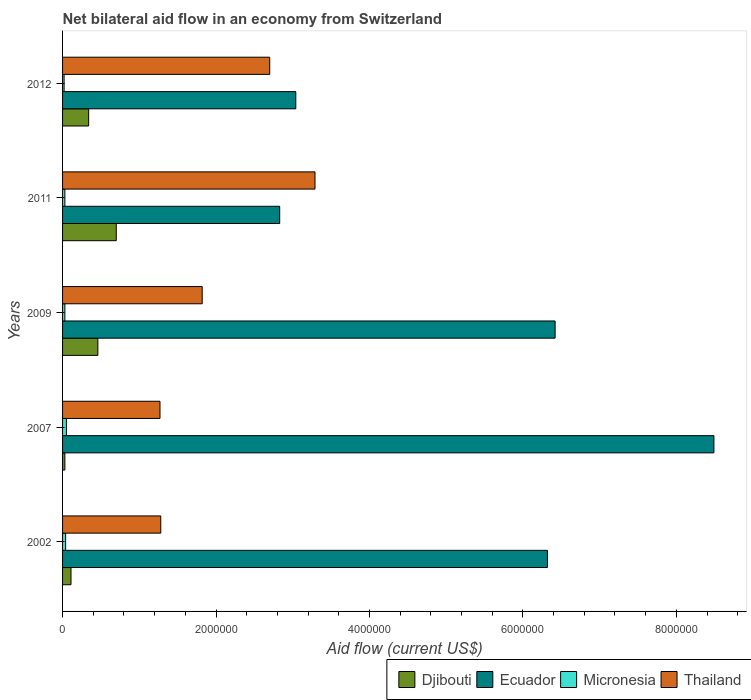How many different coloured bars are there?
Your answer should be compact. 4. How many groups of bars are there?
Your answer should be compact. 5. How many bars are there on the 5th tick from the bottom?
Offer a very short reply. 4. Across all years, what is the minimum net bilateral aid flow in Micronesia?
Your response must be concise. 2.00e+04. In which year was the net bilateral aid flow in Ecuador maximum?
Provide a short and direct response. 2007. In which year was the net bilateral aid flow in Ecuador minimum?
Provide a short and direct response. 2011. What is the total net bilateral aid flow in Djibouti in the graph?
Ensure brevity in your answer.  1.64e+06. What is the difference between the net bilateral aid flow in Thailand in 2002 and that in 2009?
Your response must be concise. -5.40e+05. What is the difference between the net bilateral aid flow in Djibouti in 2007 and the net bilateral aid flow in Thailand in 2002?
Your answer should be very brief. -1.25e+06. What is the average net bilateral aid flow in Micronesia per year?
Your response must be concise. 3.40e+04. In the year 2007, what is the difference between the net bilateral aid flow in Ecuador and net bilateral aid flow in Micronesia?
Provide a succinct answer. 8.44e+06. In how many years, is the net bilateral aid flow in Ecuador greater than 6400000 US$?
Provide a succinct answer. 2. What is the ratio of the net bilateral aid flow in Micronesia in 2002 to that in 2011?
Provide a short and direct response. 1.33. Is the net bilateral aid flow in Djibouti in 2009 less than that in 2012?
Make the answer very short. No. Is the difference between the net bilateral aid flow in Ecuador in 2002 and 2009 greater than the difference between the net bilateral aid flow in Micronesia in 2002 and 2009?
Offer a very short reply. No. What is the difference between the highest and the second highest net bilateral aid flow in Ecuador?
Your response must be concise. 2.07e+06. What is the difference between the highest and the lowest net bilateral aid flow in Djibouti?
Keep it short and to the point. 6.70e+05. Is the sum of the net bilateral aid flow in Thailand in 2011 and 2012 greater than the maximum net bilateral aid flow in Ecuador across all years?
Keep it short and to the point. No. Is it the case that in every year, the sum of the net bilateral aid flow in Ecuador and net bilateral aid flow in Djibouti is greater than the sum of net bilateral aid flow in Micronesia and net bilateral aid flow in Thailand?
Offer a very short reply. Yes. What does the 4th bar from the top in 2011 represents?
Your answer should be compact. Djibouti. What does the 1st bar from the bottom in 2007 represents?
Make the answer very short. Djibouti. Are the values on the major ticks of X-axis written in scientific E-notation?
Offer a very short reply. No. How many legend labels are there?
Your answer should be compact. 4. What is the title of the graph?
Your response must be concise. Net bilateral aid flow in an economy from Switzerland. Does "Ecuador" appear as one of the legend labels in the graph?
Your answer should be compact. Yes. What is the Aid flow (current US$) of Ecuador in 2002?
Ensure brevity in your answer.  6.32e+06. What is the Aid flow (current US$) in Thailand in 2002?
Give a very brief answer. 1.28e+06. What is the Aid flow (current US$) of Ecuador in 2007?
Your answer should be very brief. 8.49e+06. What is the Aid flow (current US$) of Micronesia in 2007?
Keep it short and to the point. 5.00e+04. What is the Aid flow (current US$) in Thailand in 2007?
Your answer should be compact. 1.27e+06. What is the Aid flow (current US$) of Ecuador in 2009?
Keep it short and to the point. 6.42e+06. What is the Aid flow (current US$) in Micronesia in 2009?
Make the answer very short. 3.00e+04. What is the Aid flow (current US$) of Thailand in 2009?
Your answer should be compact. 1.82e+06. What is the Aid flow (current US$) in Ecuador in 2011?
Provide a succinct answer. 2.83e+06. What is the Aid flow (current US$) in Thailand in 2011?
Your response must be concise. 3.29e+06. What is the Aid flow (current US$) of Ecuador in 2012?
Keep it short and to the point. 3.04e+06. What is the Aid flow (current US$) in Thailand in 2012?
Ensure brevity in your answer.  2.70e+06. Across all years, what is the maximum Aid flow (current US$) in Djibouti?
Ensure brevity in your answer.  7.00e+05. Across all years, what is the maximum Aid flow (current US$) in Ecuador?
Your answer should be very brief. 8.49e+06. Across all years, what is the maximum Aid flow (current US$) of Micronesia?
Your answer should be compact. 5.00e+04. Across all years, what is the maximum Aid flow (current US$) in Thailand?
Give a very brief answer. 3.29e+06. Across all years, what is the minimum Aid flow (current US$) of Ecuador?
Ensure brevity in your answer.  2.83e+06. Across all years, what is the minimum Aid flow (current US$) of Micronesia?
Offer a very short reply. 2.00e+04. Across all years, what is the minimum Aid flow (current US$) of Thailand?
Make the answer very short. 1.27e+06. What is the total Aid flow (current US$) of Djibouti in the graph?
Your answer should be very brief. 1.64e+06. What is the total Aid flow (current US$) in Ecuador in the graph?
Your answer should be compact. 2.71e+07. What is the total Aid flow (current US$) in Thailand in the graph?
Offer a very short reply. 1.04e+07. What is the difference between the Aid flow (current US$) of Ecuador in 2002 and that in 2007?
Your answer should be compact. -2.17e+06. What is the difference between the Aid flow (current US$) of Thailand in 2002 and that in 2007?
Give a very brief answer. 10000. What is the difference between the Aid flow (current US$) of Djibouti in 2002 and that in 2009?
Your response must be concise. -3.50e+05. What is the difference between the Aid flow (current US$) of Ecuador in 2002 and that in 2009?
Offer a very short reply. -1.00e+05. What is the difference between the Aid flow (current US$) in Thailand in 2002 and that in 2009?
Your answer should be compact. -5.40e+05. What is the difference between the Aid flow (current US$) of Djibouti in 2002 and that in 2011?
Offer a very short reply. -5.90e+05. What is the difference between the Aid flow (current US$) of Ecuador in 2002 and that in 2011?
Your response must be concise. 3.49e+06. What is the difference between the Aid flow (current US$) of Micronesia in 2002 and that in 2011?
Give a very brief answer. 10000. What is the difference between the Aid flow (current US$) of Thailand in 2002 and that in 2011?
Provide a short and direct response. -2.01e+06. What is the difference between the Aid flow (current US$) in Djibouti in 2002 and that in 2012?
Provide a succinct answer. -2.30e+05. What is the difference between the Aid flow (current US$) in Ecuador in 2002 and that in 2012?
Your response must be concise. 3.28e+06. What is the difference between the Aid flow (current US$) in Thailand in 2002 and that in 2012?
Keep it short and to the point. -1.42e+06. What is the difference between the Aid flow (current US$) of Djibouti in 2007 and that in 2009?
Your response must be concise. -4.30e+05. What is the difference between the Aid flow (current US$) of Ecuador in 2007 and that in 2009?
Keep it short and to the point. 2.07e+06. What is the difference between the Aid flow (current US$) of Thailand in 2007 and that in 2009?
Your answer should be very brief. -5.50e+05. What is the difference between the Aid flow (current US$) in Djibouti in 2007 and that in 2011?
Your answer should be compact. -6.70e+05. What is the difference between the Aid flow (current US$) of Ecuador in 2007 and that in 2011?
Your answer should be very brief. 5.66e+06. What is the difference between the Aid flow (current US$) of Thailand in 2007 and that in 2011?
Provide a succinct answer. -2.02e+06. What is the difference between the Aid flow (current US$) of Djibouti in 2007 and that in 2012?
Your response must be concise. -3.10e+05. What is the difference between the Aid flow (current US$) in Ecuador in 2007 and that in 2012?
Provide a short and direct response. 5.45e+06. What is the difference between the Aid flow (current US$) in Micronesia in 2007 and that in 2012?
Your answer should be compact. 3.00e+04. What is the difference between the Aid flow (current US$) of Thailand in 2007 and that in 2012?
Ensure brevity in your answer.  -1.43e+06. What is the difference between the Aid flow (current US$) of Djibouti in 2009 and that in 2011?
Ensure brevity in your answer.  -2.40e+05. What is the difference between the Aid flow (current US$) of Ecuador in 2009 and that in 2011?
Provide a succinct answer. 3.59e+06. What is the difference between the Aid flow (current US$) in Thailand in 2009 and that in 2011?
Your answer should be very brief. -1.47e+06. What is the difference between the Aid flow (current US$) in Djibouti in 2009 and that in 2012?
Provide a short and direct response. 1.20e+05. What is the difference between the Aid flow (current US$) in Ecuador in 2009 and that in 2012?
Your response must be concise. 3.38e+06. What is the difference between the Aid flow (current US$) in Thailand in 2009 and that in 2012?
Offer a terse response. -8.80e+05. What is the difference between the Aid flow (current US$) in Ecuador in 2011 and that in 2012?
Keep it short and to the point. -2.10e+05. What is the difference between the Aid flow (current US$) of Micronesia in 2011 and that in 2012?
Your response must be concise. 10000. What is the difference between the Aid flow (current US$) of Thailand in 2011 and that in 2012?
Your answer should be very brief. 5.90e+05. What is the difference between the Aid flow (current US$) in Djibouti in 2002 and the Aid flow (current US$) in Ecuador in 2007?
Ensure brevity in your answer.  -8.38e+06. What is the difference between the Aid flow (current US$) in Djibouti in 2002 and the Aid flow (current US$) in Micronesia in 2007?
Offer a very short reply. 6.00e+04. What is the difference between the Aid flow (current US$) in Djibouti in 2002 and the Aid flow (current US$) in Thailand in 2007?
Offer a terse response. -1.16e+06. What is the difference between the Aid flow (current US$) in Ecuador in 2002 and the Aid flow (current US$) in Micronesia in 2007?
Ensure brevity in your answer.  6.27e+06. What is the difference between the Aid flow (current US$) in Ecuador in 2002 and the Aid flow (current US$) in Thailand in 2007?
Make the answer very short. 5.05e+06. What is the difference between the Aid flow (current US$) of Micronesia in 2002 and the Aid flow (current US$) of Thailand in 2007?
Provide a succinct answer. -1.23e+06. What is the difference between the Aid flow (current US$) of Djibouti in 2002 and the Aid flow (current US$) of Ecuador in 2009?
Offer a very short reply. -6.31e+06. What is the difference between the Aid flow (current US$) in Djibouti in 2002 and the Aid flow (current US$) in Micronesia in 2009?
Provide a short and direct response. 8.00e+04. What is the difference between the Aid flow (current US$) of Djibouti in 2002 and the Aid flow (current US$) of Thailand in 2009?
Your response must be concise. -1.71e+06. What is the difference between the Aid flow (current US$) of Ecuador in 2002 and the Aid flow (current US$) of Micronesia in 2009?
Give a very brief answer. 6.29e+06. What is the difference between the Aid flow (current US$) in Ecuador in 2002 and the Aid flow (current US$) in Thailand in 2009?
Provide a succinct answer. 4.50e+06. What is the difference between the Aid flow (current US$) in Micronesia in 2002 and the Aid flow (current US$) in Thailand in 2009?
Give a very brief answer. -1.78e+06. What is the difference between the Aid flow (current US$) of Djibouti in 2002 and the Aid flow (current US$) of Ecuador in 2011?
Offer a very short reply. -2.72e+06. What is the difference between the Aid flow (current US$) of Djibouti in 2002 and the Aid flow (current US$) of Micronesia in 2011?
Ensure brevity in your answer.  8.00e+04. What is the difference between the Aid flow (current US$) in Djibouti in 2002 and the Aid flow (current US$) in Thailand in 2011?
Offer a very short reply. -3.18e+06. What is the difference between the Aid flow (current US$) in Ecuador in 2002 and the Aid flow (current US$) in Micronesia in 2011?
Keep it short and to the point. 6.29e+06. What is the difference between the Aid flow (current US$) in Ecuador in 2002 and the Aid flow (current US$) in Thailand in 2011?
Give a very brief answer. 3.03e+06. What is the difference between the Aid flow (current US$) of Micronesia in 2002 and the Aid flow (current US$) of Thailand in 2011?
Offer a very short reply. -3.25e+06. What is the difference between the Aid flow (current US$) of Djibouti in 2002 and the Aid flow (current US$) of Ecuador in 2012?
Make the answer very short. -2.93e+06. What is the difference between the Aid flow (current US$) in Djibouti in 2002 and the Aid flow (current US$) in Thailand in 2012?
Your answer should be compact. -2.59e+06. What is the difference between the Aid flow (current US$) of Ecuador in 2002 and the Aid flow (current US$) of Micronesia in 2012?
Your answer should be compact. 6.30e+06. What is the difference between the Aid flow (current US$) in Ecuador in 2002 and the Aid flow (current US$) in Thailand in 2012?
Your answer should be very brief. 3.62e+06. What is the difference between the Aid flow (current US$) in Micronesia in 2002 and the Aid flow (current US$) in Thailand in 2012?
Offer a very short reply. -2.66e+06. What is the difference between the Aid flow (current US$) in Djibouti in 2007 and the Aid flow (current US$) in Ecuador in 2009?
Provide a short and direct response. -6.39e+06. What is the difference between the Aid flow (current US$) in Djibouti in 2007 and the Aid flow (current US$) in Thailand in 2009?
Your response must be concise. -1.79e+06. What is the difference between the Aid flow (current US$) of Ecuador in 2007 and the Aid flow (current US$) of Micronesia in 2009?
Your answer should be compact. 8.46e+06. What is the difference between the Aid flow (current US$) of Ecuador in 2007 and the Aid flow (current US$) of Thailand in 2009?
Your answer should be compact. 6.67e+06. What is the difference between the Aid flow (current US$) of Micronesia in 2007 and the Aid flow (current US$) of Thailand in 2009?
Offer a terse response. -1.77e+06. What is the difference between the Aid flow (current US$) in Djibouti in 2007 and the Aid flow (current US$) in Ecuador in 2011?
Your response must be concise. -2.80e+06. What is the difference between the Aid flow (current US$) of Djibouti in 2007 and the Aid flow (current US$) of Thailand in 2011?
Provide a succinct answer. -3.26e+06. What is the difference between the Aid flow (current US$) of Ecuador in 2007 and the Aid flow (current US$) of Micronesia in 2011?
Make the answer very short. 8.46e+06. What is the difference between the Aid flow (current US$) in Ecuador in 2007 and the Aid flow (current US$) in Thailand in 2011?
Your answer should be compact. 5.20e+06. What is the difference between the Aid flow (current US$) in Micronesia in 2007 and the Aid flow (current US$) in Thailand in 2011?
Keep it short and to the point. -3.24e+06. What is the difference between the Aid flow (current US$) in Djibouti in 2007 and the Aid flow (current US$) in Ecuador in 2012?
Provide a succinct answer. -3.01e+06. What is the difference between the Aid flow (current US$) of Djibouti in 2007 and the Aid flow (current US$) of Thailand in 2012?
Make the answer very short. -2.67e+06. What is the difference between the Aid flow (current US$) in Ecuador in 2007 and the Aid flow (current US$) in Micronesia in 2012?
Make the answer very short. 8.47e+06. What is the difference between the Aid flow (current US$) in Ecuador in 2007 and the Aid flow (current US$) in Thailand in 2012?
Make the answer very short. 5.79e+06. What is the difference between the Aid flow (current US$) in Micronesia in 2007 and the Aid flow (current US$) in Thailand in 2012?
Keep it short and to the point. -2.65e+06. What is the difference between the Aid flow (current US$) of Djibouti in 2009 and the Aid flow (current US$) of Ecuador in 2011?
Keep it short and to the point. -2.37e+06. What is the difference between the Aid flow (current US$) of Djibouti in 2009 and the Aid flow (current US$) of Micronesia in 2011?
Your response must be concise. 4.30e+05. What is the difference between the Aid flow (current US$) in Djibouti in 2009 and the Aid flow (current US$) in Thailand in 2011?
Provide a short and direct response. -2.83e+06. What is the difference between the Aid flow (current US$) of Ecuador in 2009 and the Aid flow (current US$) of Micronesia in 2011?
Give a very brief answer. 6.39e+06. What is the difference between the Aid flow (current US$) in Ecuador in 2009 and the Aid flow (current US$) in Thailand in 2011?
Your answer should be very brief. 3.13e+06. What is the difference between the Aid flow (current US$) of Micronesia in 2009 and the Aid flow (current US$) of Thailand in 2011?
Offer a very short reply. -3.26e+06. What is the difference between the Aid flow (current US$) of Djibouti in 2009 and the Aid flow (current US$) of Ecuador in 2012?
Offer a terse response. -2.58e+06. What is the difference between the Aid flow (current US$) of Djibouti in 2009 and the Aid flow (current US$) of Thailand in 2012?
Offer a very short reply. -2.24e+06. What is the difference between the Aid flow (current US$) of Ecuador in 2009 and the Aid flow (current US$) of Micronesia in 2012?
Give a very brief answer. 6.40e+06. What is the difference between the Aid flow (current US$) in Ecuador in 2009 and the Aid flow (current US$) in Thailand in 2012?
Offer a very short reply. 3.72e+06. What is the difference between the Aid flow (current US$) of Micronesia in 2009 and the Aid flow (current US$) of Thailand in 2012?
Your answer should be very brief. -2.67e+06. What is the difference between the Aid flow (current US$) in Djibouti in 2011 and the Aid flow (current US$) in Ecuador in 2012?
Your response must be concise. -2.34e+06. What is the difference between the Aid flow (current US$) in Djibouti in 2011 and the Aid flow (current US$) in Micronesia in 2012?
Your answer should be very brief. 6.80e+05. What is the difference between the Aid flow (current US$) of Djibouti in 2011 and the Aid flow (current US$) of Thailand in 2012?
Ensure brevity in your answer.  -2.00e+06. What is the difference between the Aid flow (current US$) in Ecuador in 2011 and the Aid flow (current US$) in Micronesia in 2012?
Keep it short and to the point. 2.81e+06. What is the difference between the Aid flow (current US$) of Ecuador in 2011 and the Aid flow (current US$) of Thailand in 2012?
Offer a very short reply. 1.30e+05. What is the difference between the Aid flow (current US$) in Micronesia in 2011 and the Aid flow (current US$) in Thailand in 2012?
Keep it short and to the point. -2.67e+06. What is the average Aid flow (current US$) of Djibouti per year?
Your response must be concise. 3.28e+05. What is the average Aid flow (current US$) in Ecuador per year?
Offer a terse response. 5.42e+06. What is the average Aid flow (current US$) in Micronesia per year?
Offer a terse response. 3.40e+04. What is the average Aid flow (current US$) in Thailand per year?
Offer a very short reply. 2.07e+06. In the year 2002, what is the difference between the Aid flow (current US$) of Djibouti and Aid flow (current US$) of Ecuador?
Your response must be concise. -6.21e+06. In the year 2002, what is the difference between the Aid flow (current US$) in Djibouti and Aid flow (current US$) in Micronesia?
Your answer should be compact. 7.00e+04. In the year 2002, what is the difference between the Aid flow (current US$) in Djibouti and Aid flow (current US$) in Thailand?
Provide a short and direct response. -1.17e+06. In the year 2002, what is the difference between the Aid flow (current US$) of Ecuador and Aid flow (current US$) of Micronesia?
Your response must be concise. 6.28e+06. In the year 2002, what is the difference between the Aid flow (current US$) in Ecuador and Aid flow (current US$) in Thailand?
Provide a succinct answer. 5.04e+06. In the year 2002, what is the difference between the Aid flow (current US$) of Micronesia and Aid flow (current US$) of Thailand?
Give a very brief answer. -1.24e+06. In the year 2007, what is the difference between the Aid flow (current US$) of Djibouti and Aid flow (current US$) of Ecuador?
Offer a terse response. -8.46e+06. In the year 2007, what is the difference between the Aid flow (current US$) in Djibouti and Aid flow (current US$) in Micronesia?
Keep it short and to the point. -2.00e+04. In the year 2007, what is the difference between the Aid flow (current US$) of Djibouti and Aid flow (current US$) of Thailand?
Keep it short and to the point. -1.24e+06. In the year 2007, what is the difference between the Aid flow (current US$) in Ecuador and Aid flow (current US$) in Micronesia?
Provide a short and direct response. 8.44e+06. In the year 2007, what is the difference between the Aid flow (current US$) in Ecuador and Aid flow (current US$) in Thailand?
Offer a terse response. 7.22e+06. In the year 2007, what is the difference between the Aid flow (current US$) of Micronesia and Aid flow (current US$) of Thailand?
Offer a terse response. -1.22e+06. In the year 2009, what is the difference between the Aid flow (current US$) of Djibouti and Aid flow (current US$) of Ecuador?
Your response must be concise. -5.96e+06. In the year 2009, what is the difference between the Aid flow (current US$) of Djibouti and Aid flow (current US$) of Thailand?
Ensure brevity in your answer.  -1.36e+06. In the year 2009, what is the difference between the Aid flow (current US$) in Ecuador and Aid flow (current US$) in Micronesia?
Your response must be concise. 6.39e+06. In the year 2009, what is the difference between the Aid flow (current US$) of Ecuador and Aid flow (current US$) of Thailand?
Your answer should be compact. 4.60e+06. In the year 2009, what is the difference between the Aid flow (current US$) of Micronesia and Aid flow (current US$) of Thailand?
Offer a terse response. -1.79e+06. In the year 2011, what is the difference between the Aid flow (current US$) of Djibouti and Aid flow (current US$) of Ecuador?
Your answer should be very brief. -2.13e+06. In the year 2011, what is the difference between the Aid flow (current US$) of Djibouti and Aid flow (current US$) of Micronesia?
Keep it short and to the point. 6.70e+05. In the year 2011, what is the difference between the Aid flow (current US$) in Djibouti and Aid flow (current US$) in Thailand?
Your answer should be compact. -2.59e+06. In the year 2011, what is the difference between the Aid flow (current US$) in Ecuador and Aid flow (current US$) in Micronesia?
Your answer should be compact. 2.80e+06. In the year 2011, what is the difference between the Aid flow (current US$) of Ecuador and Aid flow (current US$) of Thailand?
Ensure brevity in your answer.  -4.60e+05. In the year 2011, what is the difference between the Aid flow (current US$) in Micronesia and Aid flow (current US$) in Thailand?
Give a very brief answer. -3.26e+06. In the year 2012, what is the difference between the Aid flow (current US$) in Djibouti and Aid flow (current US$) in Ecuador?
Ensure brevity in your answer.  -2.70e+06. In the year 2012, what is the difference between the Aid flow (current US$) of Djibouti and Aid flow (current US$) of Thailand?
Ensure brevity in your answer.  -2.36e+06. In the year 2012, what is the difference between the Aid flow (current US$) in Ecuador and Aid flow (current US$) in Micronesia?
Give a very brief answer. 3.02e+06. In the year 2012, what is the difference between the Aid flow (current US$) of Ecuador and Aid flow (current US$) of Thailand?
Provide a short and direct response. 3.40e+05. In the year 2012, what is the difference between the Aid flow (current US$) of Micronesia and Aid flow (current US$) of Thailand?
Provide a succinct answer. -2.68e+06. What is the ratio of the Aid flow (current US$) in Djibouti in 2002 to that in 2007?
Your answer should be compact. 3.67. What is the ratio of the Aid flow (current US$) in Ecuador in 2002 to that in 2007?
Make the answer very short. 0.74. What is the ratio of the Aid flow (current US$) of Thailand in 2002 to that in 2007?
Make the answer very short. 1.01. What is the ratio of the Aid flow (current US$) in Djibouti in 2002 to that in 2009?
Make the answer very short. 0.24. What is the ratio of the Aid flow (current US$) of Ecuador in 2002 to that in 2009?
Offer a terse response. 0.98. What is the ratio of the Aid flow (current US$) of Micronesia in 2002 to that in 2009?
Offer a very short reply. 1.33. What is the ratio of the Aid flow (current US$) of Thailand in 2002 to that in 2009?
Make the answer very short. 0.7. What is the ratio of the Aid flow (current US$) of Djibouti in 2002 to that in 2011?
Make the answer very short. 0.16. What is the ratio of the Aid flow (current US$) in Ecuador in 2002 to that in 2011?
Provide a short and direct response. 2.23. What is the ratio of the Aid flow (current US$) of Micronesia in 2002 to that in 2011?
Your response must be concise. 1.33. What is the ratio of the Aid flow (current US$) of Thailand in 2002 to that in 2011?
Offer a terse response. 0.39. What is the ratio of the Aid flow (current US$) in Djibouti in 2002 to that in 2012?
Ensure brevity in your answer.  0.32. What is the ratio of the Aid flow (current US$) in Ecuador in 2002 to that in 2012?
Your response must be concise. 2.08. What is the ratio of the Aid flow (current US$) of Thailand in 2002 to that in 2012?
Provide a succinct answer. 0.47. What is the ratio of the Aid flow (current US$) in Djibouti in 2007 to that in 2009?
Offer a terse response. 0.07. What is the ratio of the Aid flow (current US$) in Ecuador in 2007 to that in 2009?
Provide a short and direct response. 1.32. What is the ratio of the Aid flow (current US$) in Thailand in 2007 to that in 2009?
Keep it short and to the point. 0.7. What is the ratio of the Aid flow (current US$) of Djibouti in 2007 to that in 2011?
Provide a short and direct response. 0.04. What is the ratio of the Aid flow (current US$) of Ecuador in 2007 to that in 2011?
Provide a short and direct response. 3. What is the ratio of the Aid flow (current US$) of Micronesia in 2007 to that in 2011?
Make the answer very short. 1.67. What is the ratio of the Aid flow (current US$) in Thailand in 2007 to that in 2011?
Your answer should be very brief. 0.39. What is the ratio of the Aid flow (current US$) in Djibouti in 2007 to that in 2012?
Your answer should be compact. 0.09. What is the ratio of the Aid flow (current US$) of Ecuador in 2007 to that in 2012?
Provide a succinct answer. 2.79. What is the ratio of the Aid flow (current US$) in Thailand in 2007 to that in 2012?
Provide a short and direct response. 0.47. What is the ratio of the Aid flow (current US$) of Djibouti in 2009 to that in 2011?
Your response must be concise. 0.66. What is the ratio of the Aid flow (current US$) of Ecuador in 2009 to that in 2011?
Keep it short and to the point. 2.27. What is the ratio of the Aid flow (current US$) in Thailand in 2009 to that in 2011?
Provide a short and direct response. 0.55. What is the ratio of the Aid flow (current US$) of Djibouti in 2009 to that in 2012?
Keep it short and to the point. 1.35. What is the ratio of the Aid flow (current US$) in Ecuador in 2009 to that in 2012?
Give a very brief answer. 2.11. What is the ratio of the Aid flow (current US$) of Micronesia in 2009 to that in 2012?
Provide a succinct answer. 1.5. What is the ratio of the Aid flow (current US$) of Thailand in 2009 to that in 2012?
Your answer should be compact. 0.67. What is the ratio of the Aid flow (current US$) of Djibouti in 2011 to that in 2012?
Ensure brevity in your answer.  2.06. What is the ratio of the Aid flow (current US$) in Ecuador in 2011 to that in 2012?
Offer a terse response. 0.93. What is the ratio of the Aid flow (current US$) in Thailand in 2011 to that in 2012?
Give a very brief answer. 1.22. What is the difference between the highest and the second highest Aid flow (current US$) of Ecuador?
Your answer should be very brief. 2.07e+06. What is the difference between the highest and the second highest Aid flow (current US$) of Micronesia?
Provide a succinct answer. 10000. What is the difference between the highest and the second highest Aid flow (current US$) in Thailand?
Ensure brevity in your answer.  5.90e+05. What is the difference between the highest and the lowest Aid flow (current US$) of Djibouti?
Make the answer very short. 6.70e+05. What is the difference between the highest and the lowest Aid flow (current US$) in Ecuador?
Provide a short and direct response. 5.66e+06. What is the difference between the highest and the lowest Aid flow (current US$) of Thailand?
Your answer should be very brief. 2.02e+06. 